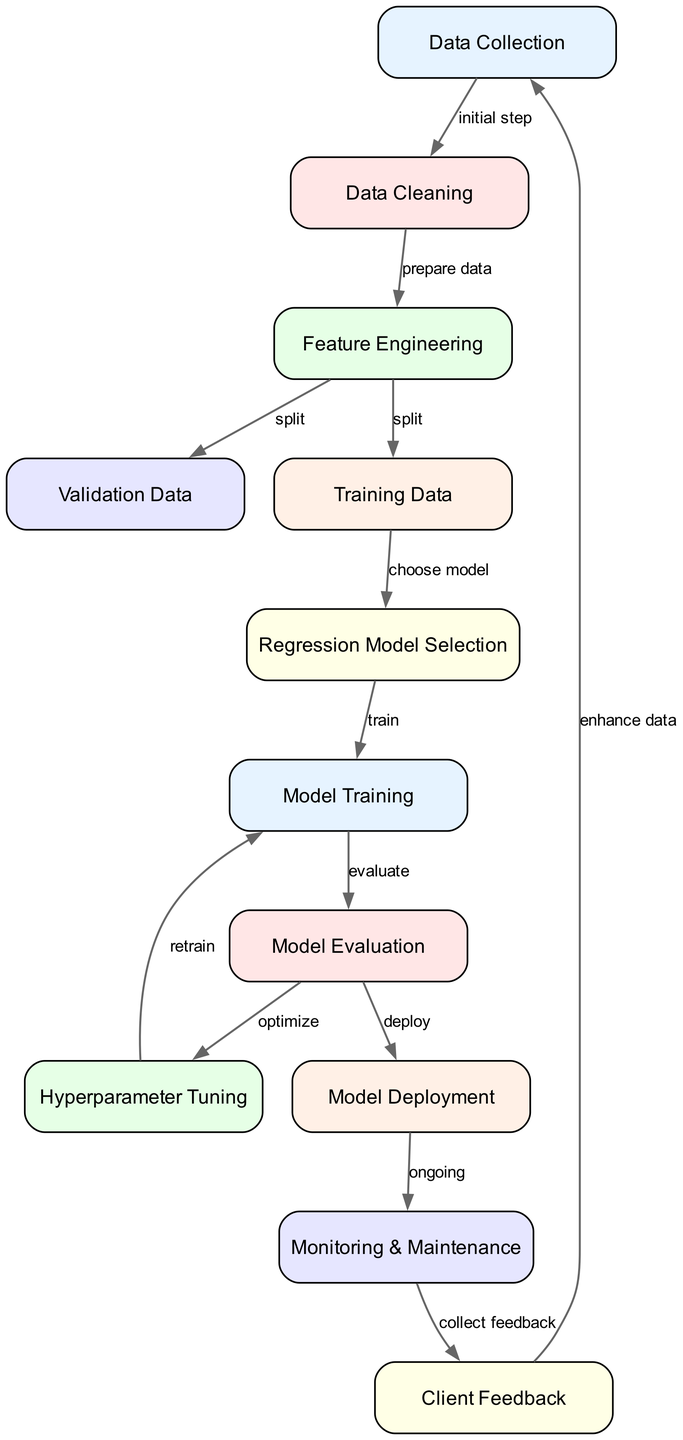What is the first step in the process? The diagram shows the first node labeled "Data Collection," indicating that this is the initial step in the optimization process.
Answer: Data Collection How many nodes are in the diagram? By counting the listed nodes, we find there are a total of twelve nodes in the diagram.
Answer: 12 Which node comes after "Model Evaluation"? The flow from the "Model Evaluation" node proceeds to the "Hyperparameter Tuning" node, indicating the next step in the process.
Answer: Hyperparameter Tuning What is the relationship between "Model Training" and "Model Evaluation"? The diagram indicates that "Model Training" is followed by "Model Evaluation," suggesting that evaluation occurs after the model is trained.
Answer: train Which step includes collecting feedback from clients? The process node labeled "Client Feedback" focuses specifically on gathering feedback from clients after deploying the model.
Answer: Client Feedback What happens after "Model Deployment"? According to the diagram, after the "Model Deployment," the next step is "Monitoring & Maintenance," indicating ongoing oversight of the deployed model.
Answer: Monitoring & Maintenance Which nodes are directly connected to "Feature Engineering"? "Feature Engineering" connects directly to both "Training Data" and "Validation Data" nodes, indicating it prepares the data for both training and validation purposes.
Answer: Training Data, Validation Data Do we see any nodes dedicated to model selection? Yes, the "Regression Model Selection" node is explicitly mentioned as part of the process, indicating a dedicated step for selecting the appropriate regression model.
Answer: Regression Model Selection What is the final step in the process? The last node in the flow is "Client Feedback," suggesting that this is the concluding step in the continuous improvement loop of the model.
Answer: Client Feedback 